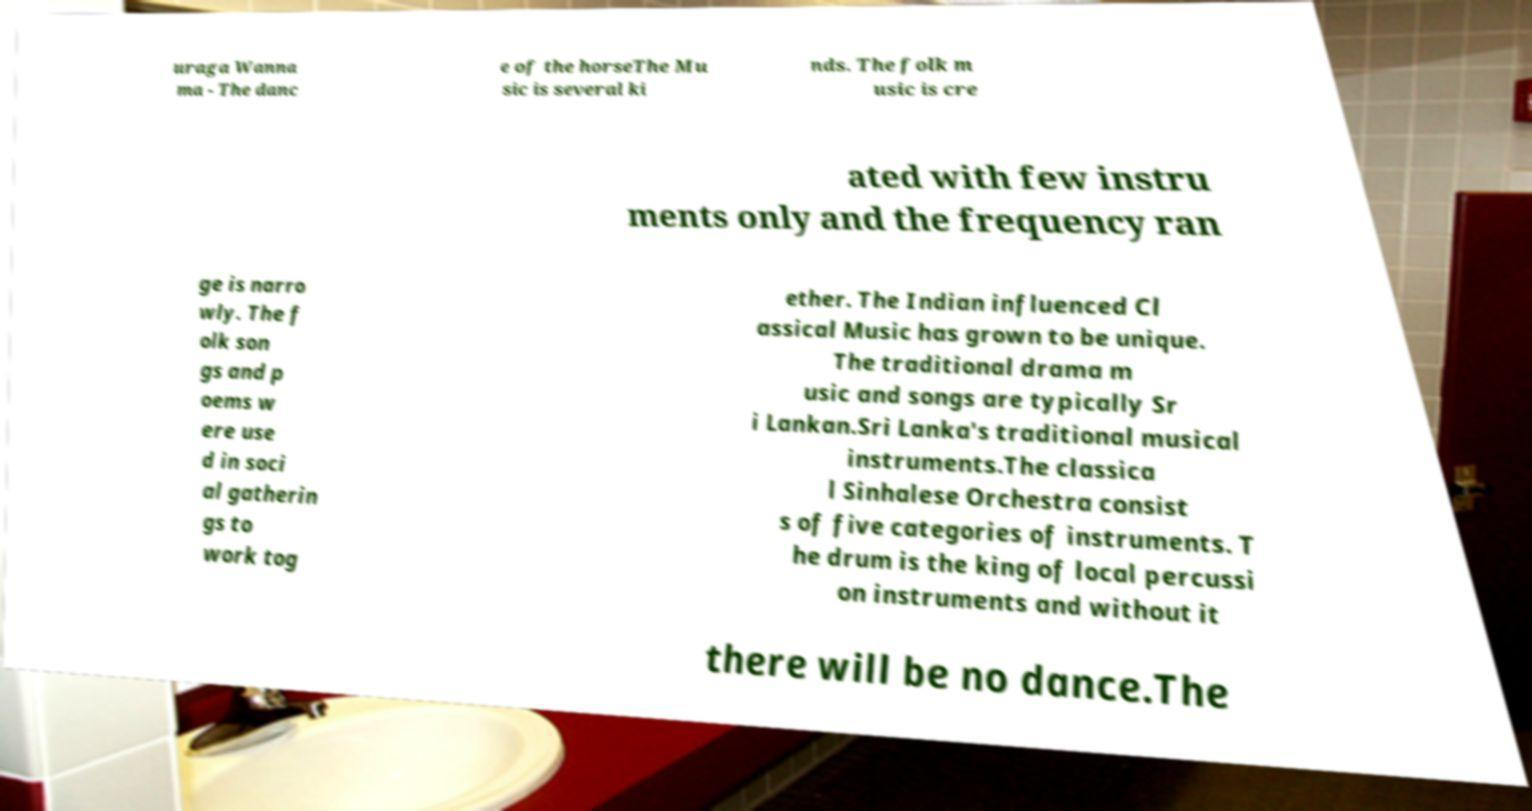What messages or text are displayed in this image? I need them in a readable, typed format. uraga Wanna ma - The danc e of the horseThe Mu sic is several ki nds. The folk m usic is cre ated with few instru ments only and the frequency ran ge is narro wly. The f olk son gs and p oems w ere use d in soci al gatherin gs to work tog ether. The Indian influenced Cl assical Music has grown to be unique. The traditional drama m usic and songs are typically Sr i Lankan.Sri Lanka's traditional musical instruments.The classica l Sinhalese Orchestra consist s of five categories of instruments. T he drum is the king of local percussi on instruments and without it there will be no dance.The 